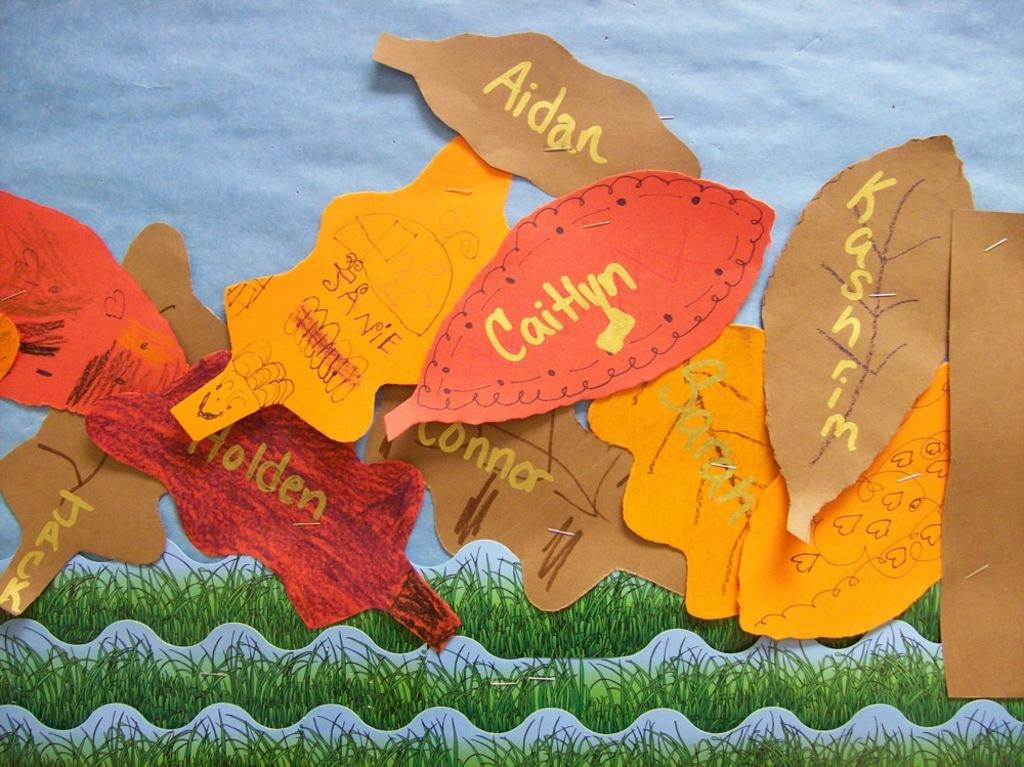What type of material is visible on the sheets of paper in the image? Names are written on the sheets of paper in the image. What color is the surface on which the sheets of paper are placed? The sheets of paper are placed on a blue surface. What type of metal is used to create the quarter visible in the image? There is no quarter visible in the image; it only features sheets of paper with names written on them and a blue surface. 